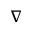Convert formula to latex. <formula><loc_0><loc_0><loc_500><loc_500>\nabla</formula> 